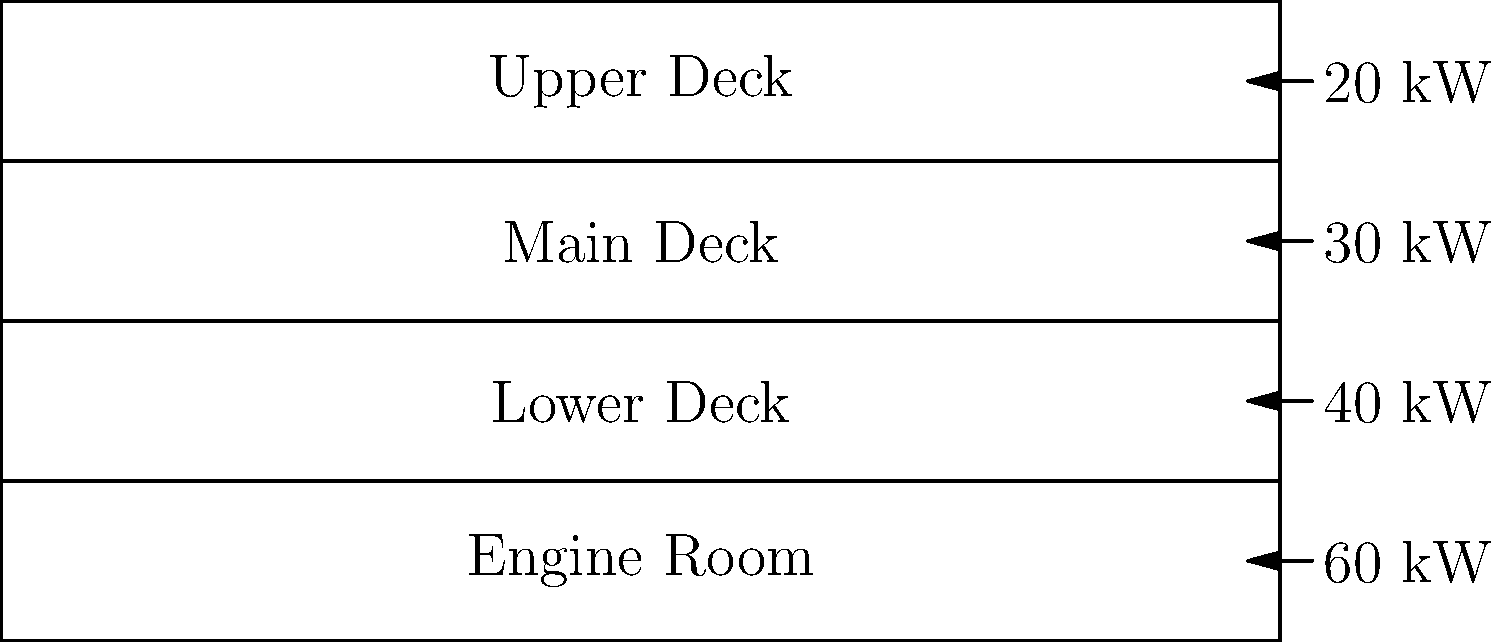Given the cross-sectional diagram of an ocean liner showing electrical load distribution across various decks, calculate the total electrical load of the ship and determine what percentage of the total load is consumed by the engine room. To solve this problem, we'll follow these steps:

1. Identify the electrical load for each deck:
   - Upper Deck: 20 kW
   - Main Deck: 30 kW
   - Lower Deck: 40 kW
   - Engine Room: 60 kW

2. Calculate the total electrical load:
   $Total Load = 20 + 30 + 40 + 60 = 150$ kW

3. Calculate the percentage of total load consumed by the engine room:
   $Percentage = \frac{Engine Room Load}{Total Load} \times 100\%$
   $Percentage = \frac{60}{150} \times 100\% = 40\%$

Therefore, the total electrical load of the ship is 150 kW, and the engine room consumes 40% of the total load.
Answer: 150 kW total load; 40% consumed by engine room 